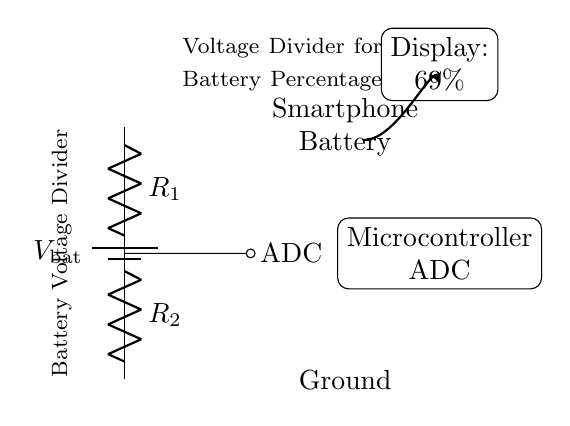What type of circuit is shown? The circuit represented is a voltage divider, which consists of two resistors in series to divide voltage.
Answer: Voltage divider What does the microcontroller ADC measure? The microcontroller ADC measures the voltage at the midpoint between the resistors, representing the battery percentage.
Answer: Battery percentage What is the output percentage displayed? The display shows a percentage value that corresponds to the voltage reading from the divider circuit, which in this case is sixty-nine percent.
Answer: Sixty-nine percent What is the symbol for the battery in this circuit? The battery is represented by the battery symbol which indicates a source of voltage, in this case, the smartphone battery.
Answer: Battery symbol How many resistors are used in this voltage divider? Two resistors are used in the voltage divider to create the necessary voltage division for the ADC input.
Answer: Two What happens if one of the resistors fails? If one resistor fails, the voltage divider will not function correctly, leading to inaccurate battery voltage readings and potentially incorrect display values.
Answer: Inaccurate readings Why is the ADC used in this circuit? The ADC is used to convert the analog voltage from the voltage divider into a digital signal that the microcontroller can process and display.
Answer: To convert analog voltage to digital 